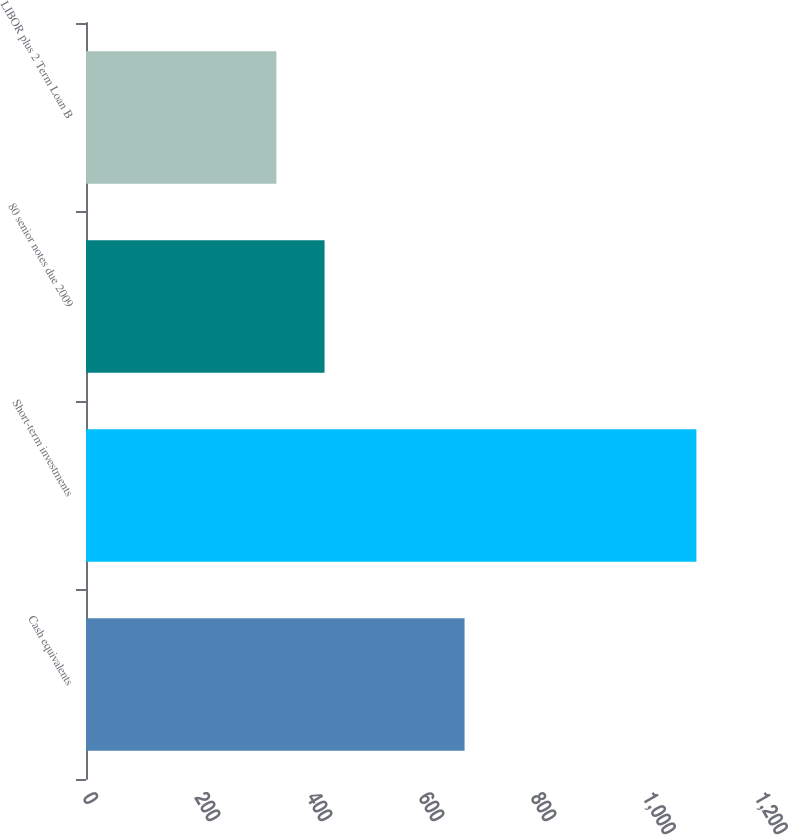<chart> <loc_0><loc_0><loc_500><loc_500><bar_chart><fcel>Cash equivalents<fcel>Short-term investments<fcel>80 senior notes due 2009<fcel>LIBOR plus 2 Term Loan B<nl><fcel>676<fcel>1090<fcel>426<fcel>340<nl></chart> 